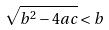Convert formula to latex. <formula><loc_0><loc_0><loc_500><loc_500>\sqrt { b ^ { 2 } - 4 a c } < b</formula> 